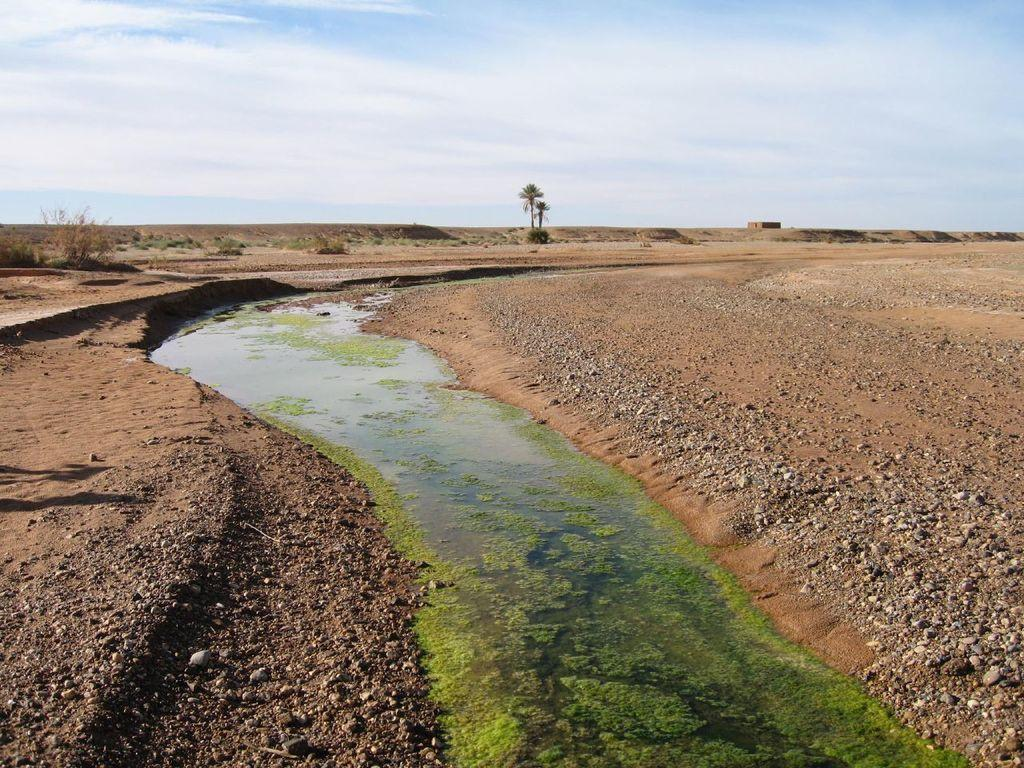What is the main subject in the center of the image? There is water in the center of the image. What can be seen on both the right and left sides of the image? There are stones and sand on both the right and left sides of the image. What is visible in the background of the image? There are trees and the sky visible in the background of the image. Where is the kitten wearing a hat in the image? There is no kitten or hat present in the image. What type of art can be seen in the image? There is no art present in the image; it features water, stones, sand, trees, and the sky. 